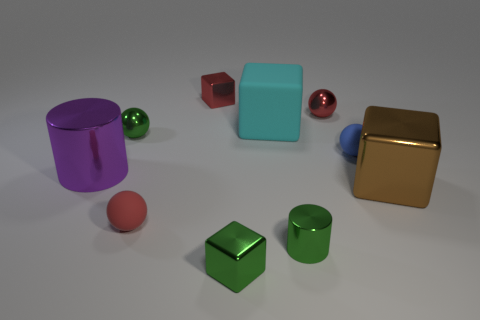There is a brown thing that is the same size as the cyan thing; what is its material?
Provide a short and direct response. Metal. There is a red ball right of the red matte object; does it have the same size as the brown cube?
Make the answer very short. No. Do the small red object in front of the large brown shiny object and the brown metallic object have the same shape?
Your answer should be compact. No. What number of things are either tiny matte spheres or tiny red things that are right of the tiny green shiny cylinder?
Keep it short and to the point. 3. Is the number of big brown objects less than the number of tiny objects?
Your response must be concise. Yes. Is the number of tiny blue matte balls greater than the number of big gray spheres?
Provide a succinct answer. Yes. What number of other things are there of the same material as the large brown block
Ensure brevity in your answer.  6. What number of tiny metal cylinders are behind the green metallic object that is behind the metal cylinder that is behind the small green metal cylinder?
Provide a succinct answer. 0. How many rubber things are either small red balls or small cyan blocks?
Your answer should be very brief. 1. There is a rubber thing that is behind the tiny rubber object on the right side of the big cyan thing; what is its size?
Provide a succinct answer. Large. 